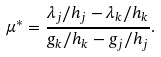<formula> <loc_0><loc_0><loc_500><loc_500>\mu ^ { \ast } = \frac { \lambda _ { j } / h _ { j } - \lambda _ { k } / h _ { k } } { g _ { k } / h _ { k } - g _ { j } / h _ { j } } .</formula> 